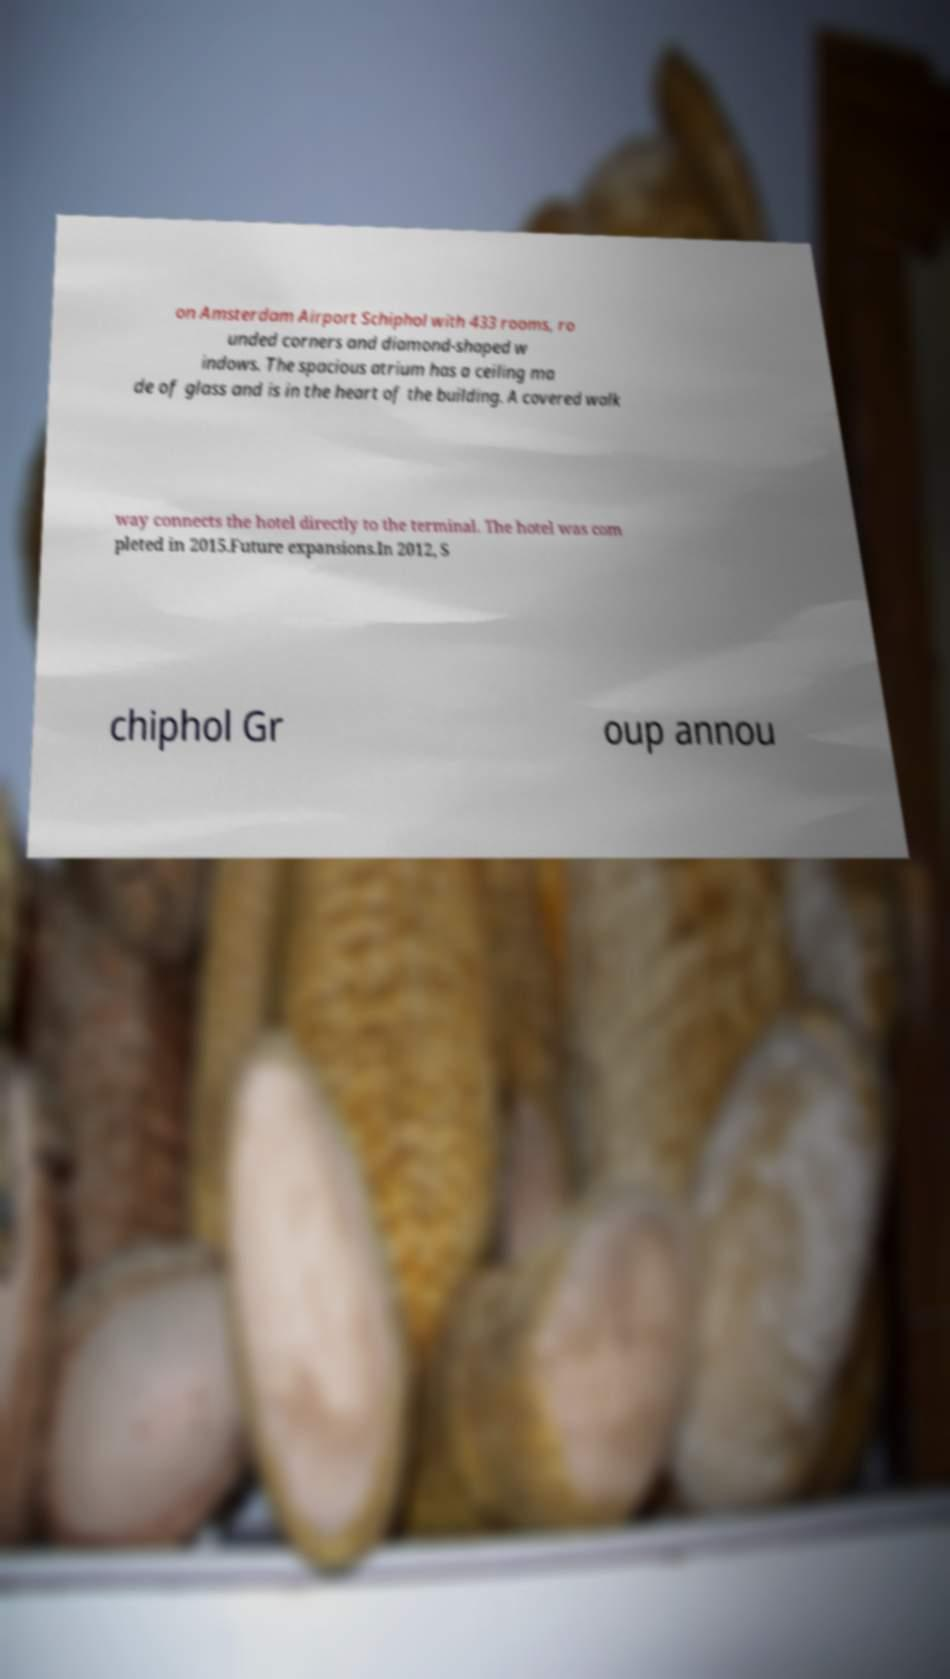Please identify and transcribe the text found in this image. on Amsterdam Airport Schiphol with 433 rooms, ro unded corners and diamond-shaped w indows. The spacious atrium has a ceiling ma de of glass and is in the heart of the building. A covered walk way connects the hotel directly to the terminal. The hotel was com pleted in 2015.Future expansions.In 2012, S chiphol Gr oup annou 